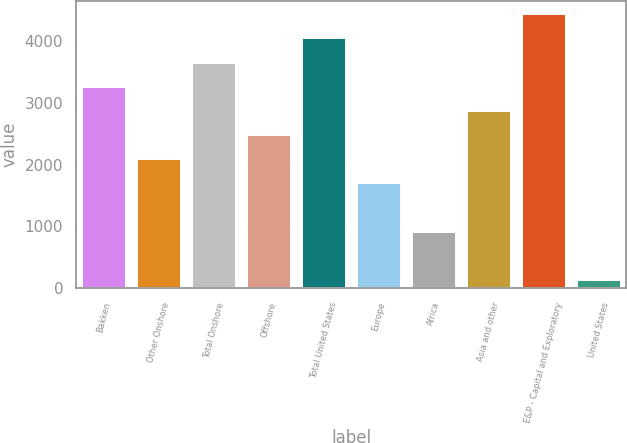Convert chart. <chart><loc_0><loc_0><loc_500><loc_500><bar_chart><fcel>Bakken<fcel>Other Onshore<fcel>Total Onshore<fcel>Offshore<fcel>Total United States<fcel>Europe<fcel>Africa<fcel>Asia and other<fcel>E&P - Capital and Exploratory<fcel>United States<nl><fcel>3260<fcel>2087<fcel>3651<fcel>2478<fcel>4042<fcel>1696<fcel>914<fcel>2869<fcel>4433<fcel>132<nl></chart> 